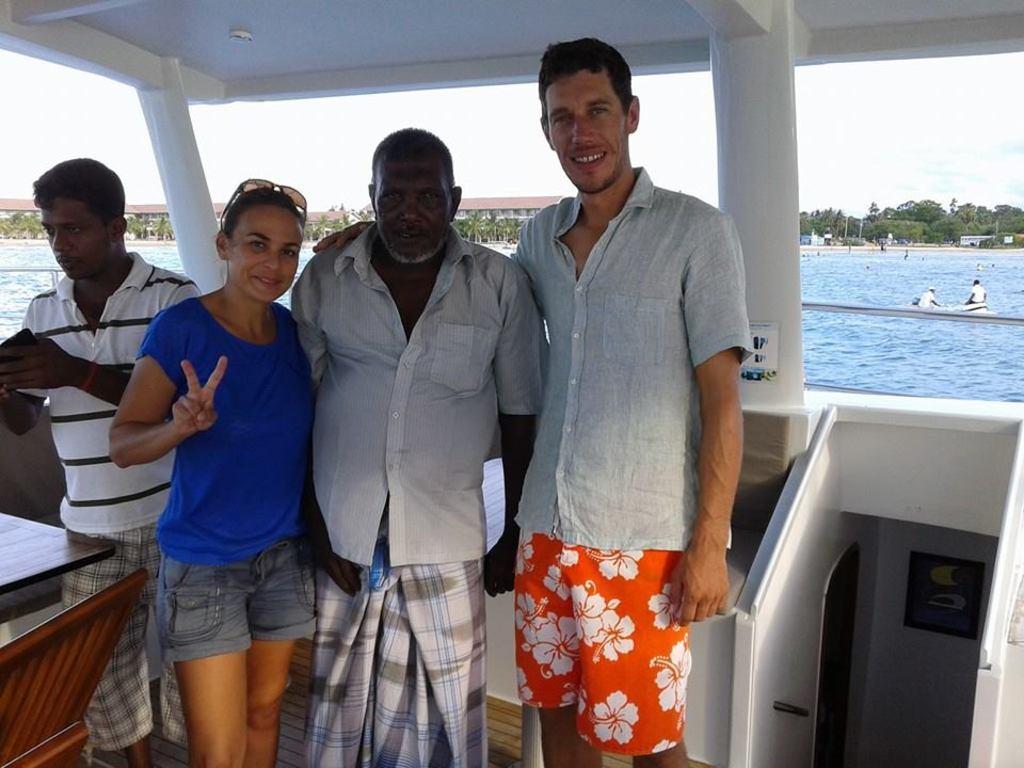In one or two sentences, can you explain what this image depicts? In the center of the image four persons are standing. In the middle of the image we can see water, trees, buildings are present. At the top of the image sky is there. In the background of the image boats are present. 